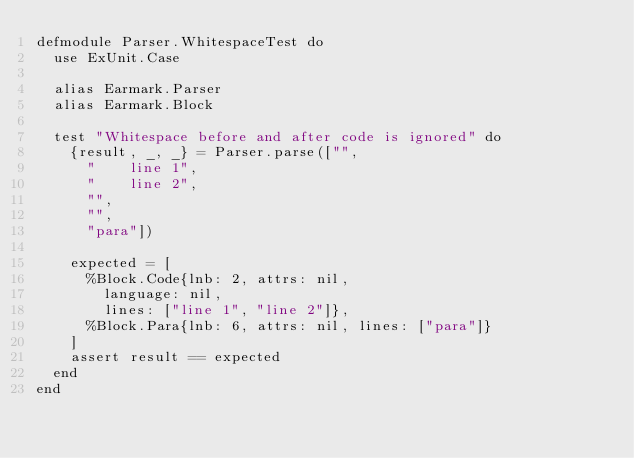<code> <loc_0><loc_0><loc_500><loc_500><_Elixir_>defmodule Parser.WhitespaceTest do
  use ExUnit.Case

  alias Earmark.Parser
  alias Earmark.Block

  test "Whitespace before and after code is ignored" do
    {result, _, _} = Parser.parse(["",
      "    line 1",
      "    line 2",
      "",
      "",
      "para"])

    expected = [
      %Block.Code{lnb: 2, attrs: nil,
        language: nil,
        lines: ["line 1", "line 2"]},
      %Block.Para{lnb: 6, attrs: nil, lines: ["para"]}
    ]
    assert result == expected
  end
end

</code> 